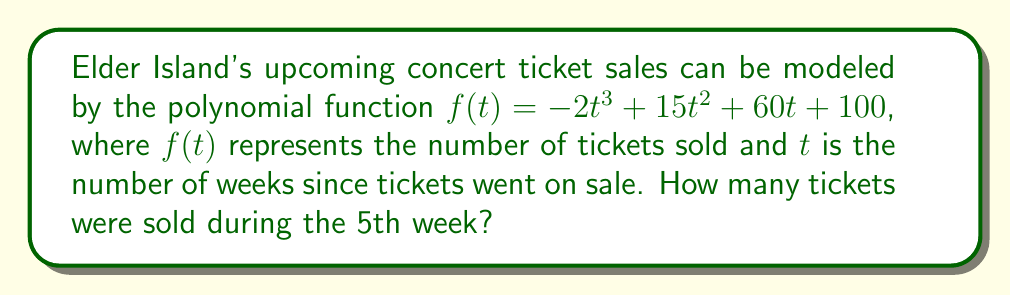Solve this math problem. To find the number of tickets sold during the 5th week, we need to:

1. Calculate the total tickets sold at the end of week 5: $f(5)$
2. Calculate the total tickets sold at the end of week 4: $f(4)$
3. Subtract $f(4)$ from $f(5)$ to get the tickets sold in week 5

Step 1: Calculate $f(5)$
$$\begin{aligned}
f(5) &= -2(5^3) + 15(5^2) + 60(5) + 100 \\
&= -2(125) + 15(25) + 60(5) + 100 \\
&= -250 + 375 + 300 + 100 \\
&= 525
\end{aligned}$$

Step 2: Calculate $f(4)$
$$\begin{aligned}
f(4) &= -2(4^3) + 15(4^2) + 60(4) + 100 \\
&= -2(64) + 15(16) + 60(4) + 100 \\
&= -128 + 240 + 240 + 100 \\
&= 452
\end{aligned}$$

Step 3: Subtract $f(4)$ from $f(5)$
$$525 - 452 = 73$$

Therefore, 73 tickets were sold during the 5th week.
Answer: 73 tickets 